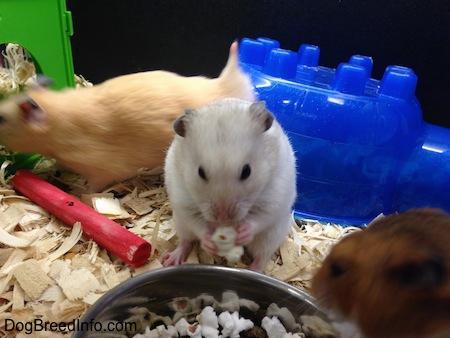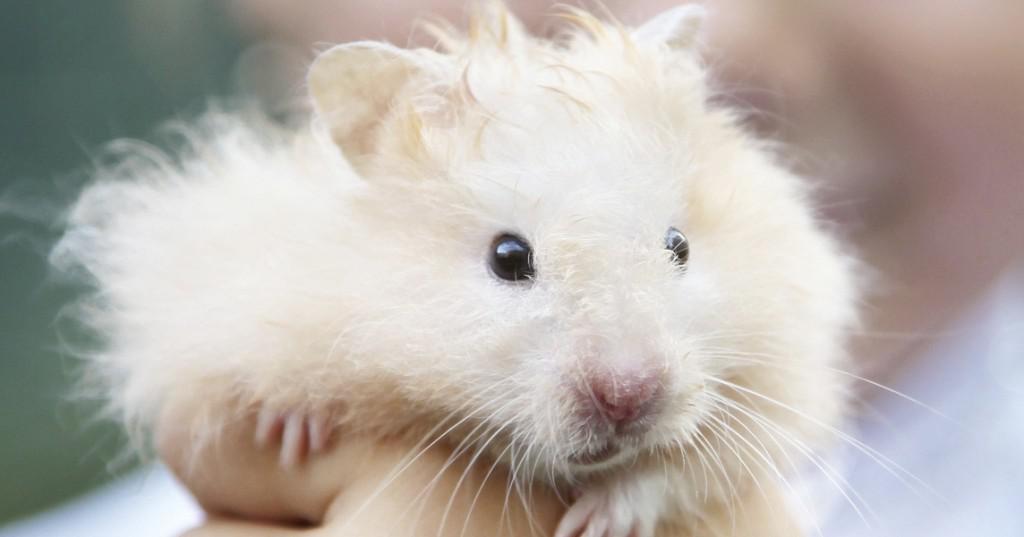The first image is the image on the left, the second image is the image on the right. For the images displayed, is the sentence "There are exactly two hamsters" factually correct? Answer yes or no. No. The first image is the image on the left, the second image is the image on the right. Given the left and right images, does the statement "There are two mice." hold true? Answer yes or no. No. 